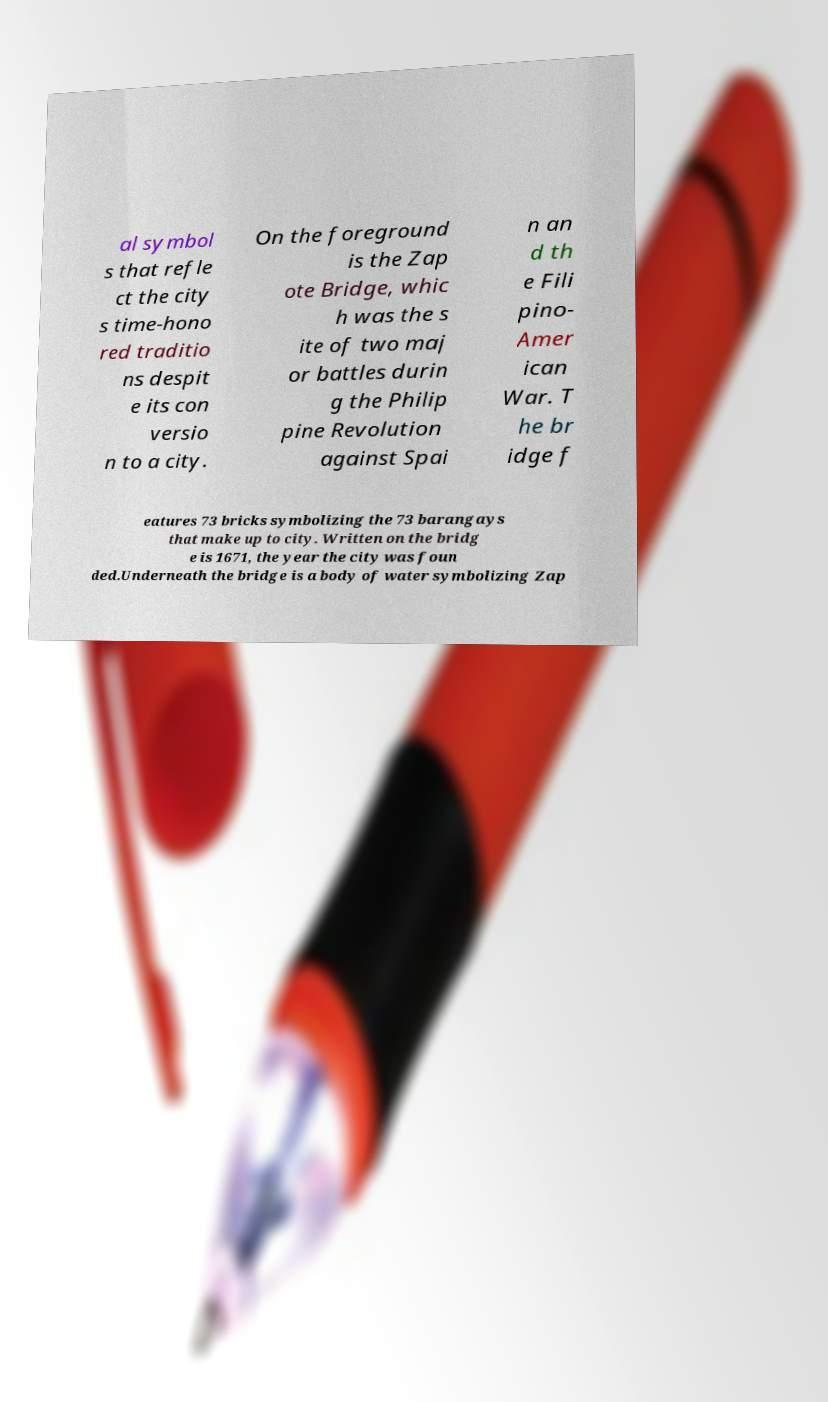For documentation purposes, I need the text within this image transcribed. Could you provide that? al symbol s that refle ct the city s time-hono red traditio ns despit e its con versio n to a city. On the foreground is the Zap ote Bridge, whic h was the s ite of two maj or battles durin g the Philip pine Revolution against Spai n an d th e Fili pino- Amer ican War. T he br idge f eatures 73 bricks symbolizing the 73 barangays that make up to city. Written on the bridg e is 1671, the year the city was foun ded.Underneath the bridge is a body of water symbolizing Zap 